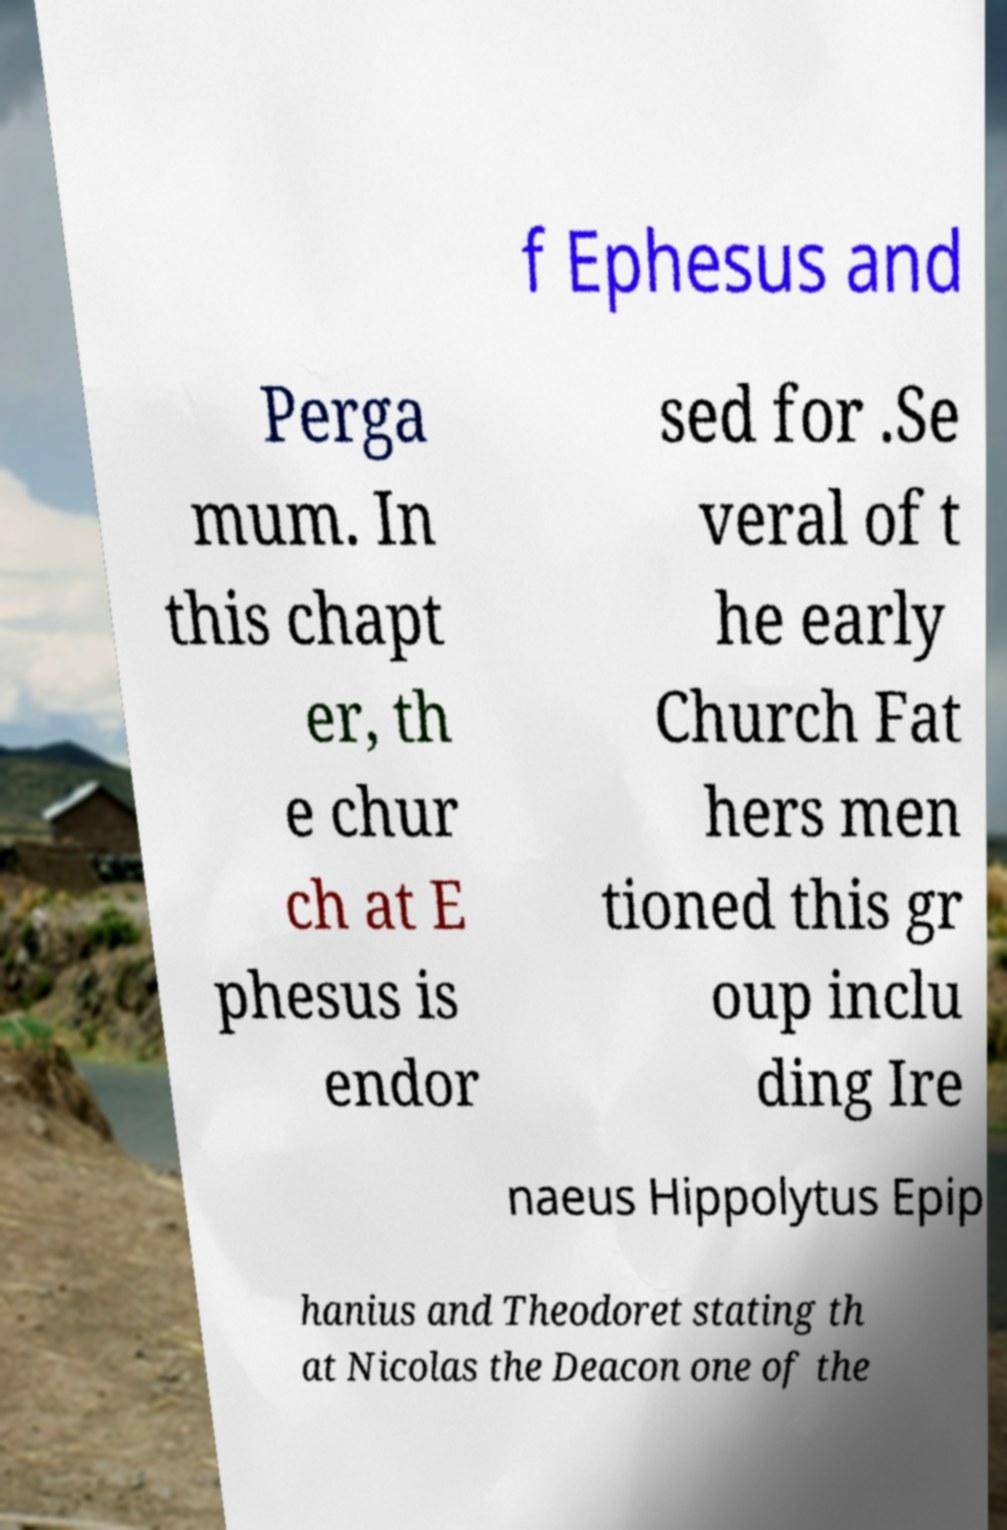Please identify and transcribe the text found in this image. f Ephesus and Perga mum. In this chapt er, th e chur ch at E phesus is endor sed for .Se veral of t he early Church Fat hers men tioned this gr oup inclu ding Ire naeus Hippolytus Epip hanius and Theodoret stating th at Nicolas the Deacon one of the 